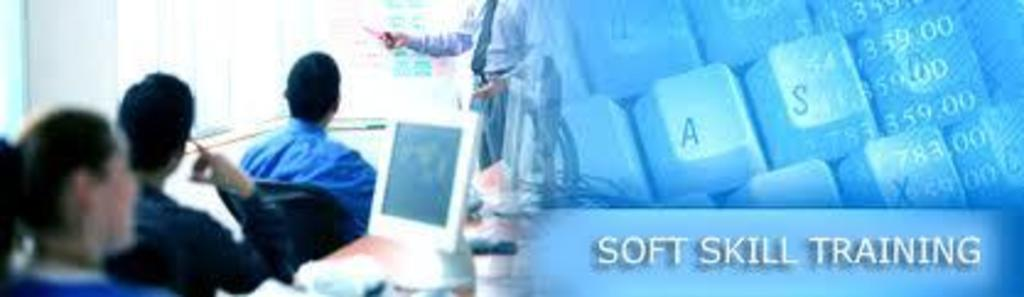What device is located on the right side of the image? There is a keyboard on the right side of the image. What is written or displayed on the right side of the image? Text is present on the right side of the image. What can be seen on the left side of the image? There is a computer and persons on the left side of the image. What type of powder is being used by the persons on the left side of the image? There is no powder present in the image; it features a keyboard, text, a computer, and persons. What color is the silver object on the right side of the image? There is no silver object present in the image. 